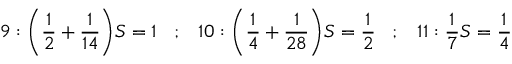<formula> <loc_0><loc_0><loc_500><loc_500>9 \colon { \left ( } { \frac { 1 } { 2 } } + { \frac { 1 } { 1 4 } } { \right ) } S = 1 \, ; \, 1 0 \colon { \left ( } { \frac { 1 } { 4 } } + { \frac { 1 } { 2 8 } } { \right ) } S = { \frac { 1 } { 2 } } \, ; \, 1 1 \colon { \frac { 1 } { 7 } } S = { \frac { 1 } { 4 } }</formula> 